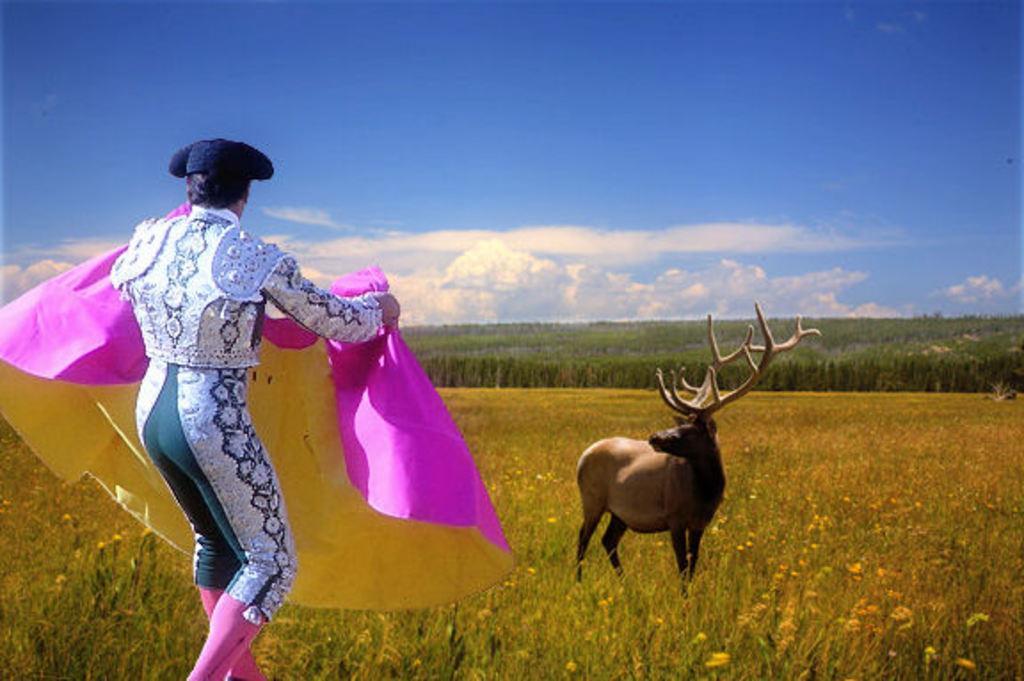How would you summarize this image in a sentence or two? This is an edited image. I can see a person standing and holding a cloth. In front of the person, there are plants with flowers, trees and a deer. In the background, there is the sky. 